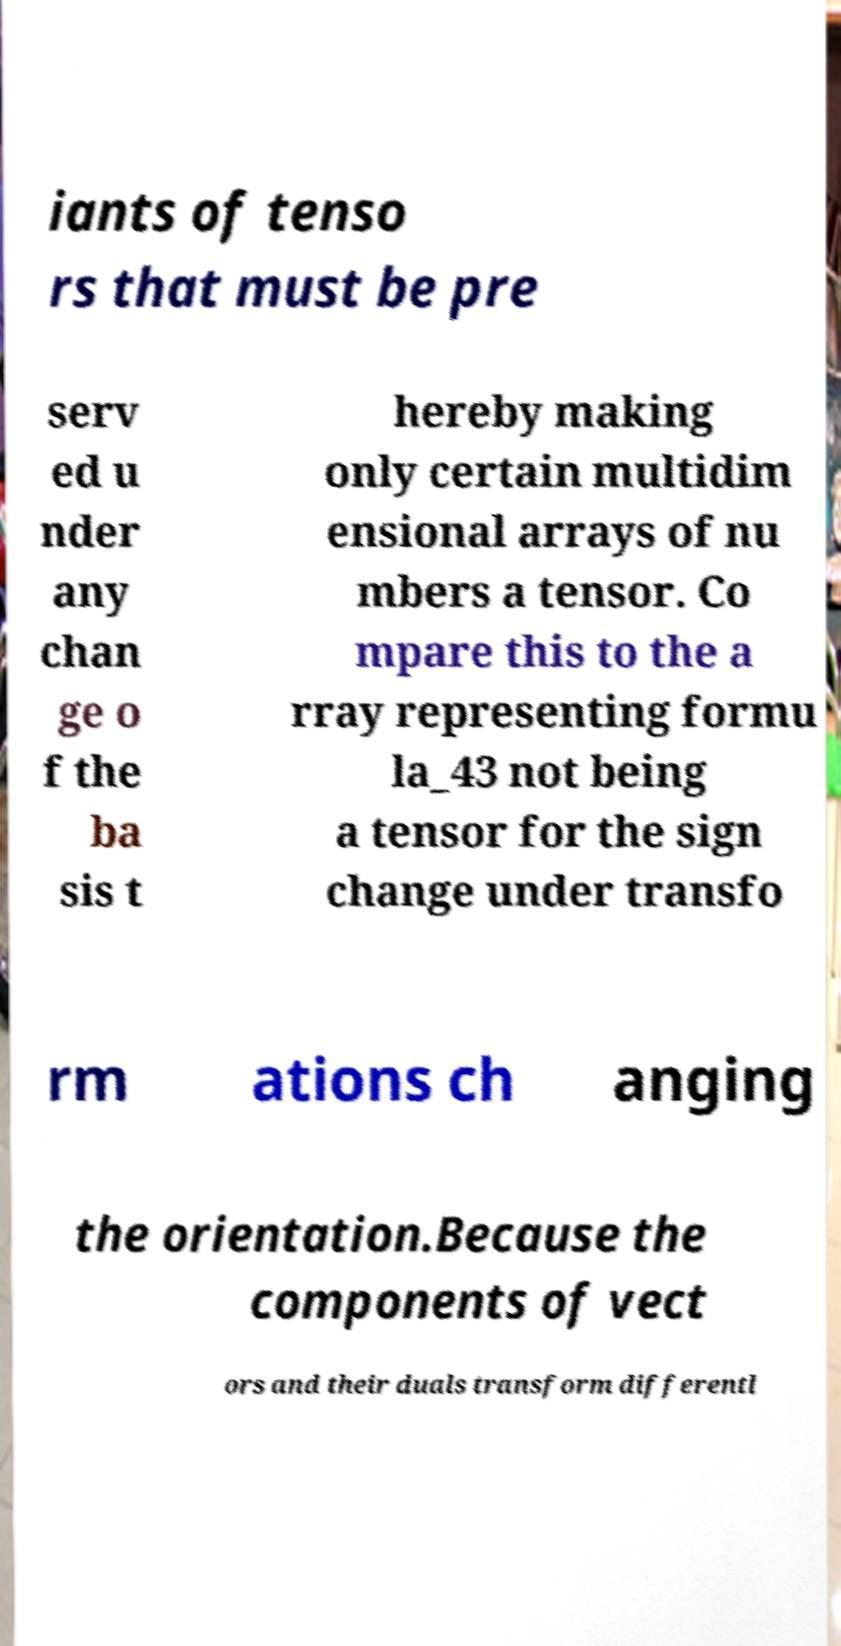Please read and relay the text visible in this image. What does it say? iants of tenso rs that must be pre serv ed u nder any chan ge o f the ba sis t hereby making only certain multidim ensional arrays of nu mbers a tensor. Co mpare this to the a rray representing formu la_43 not being a tensor for the sign change under transfo rm ations ch anging the orientation.Because the components of vect ors and their duals transform differentl 